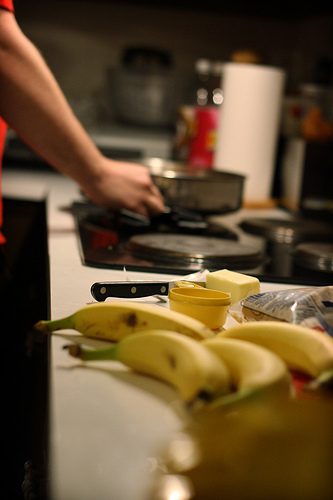Are there cars or bags in this image? There is a visible bag on the right side of the image, but no cars are present. 